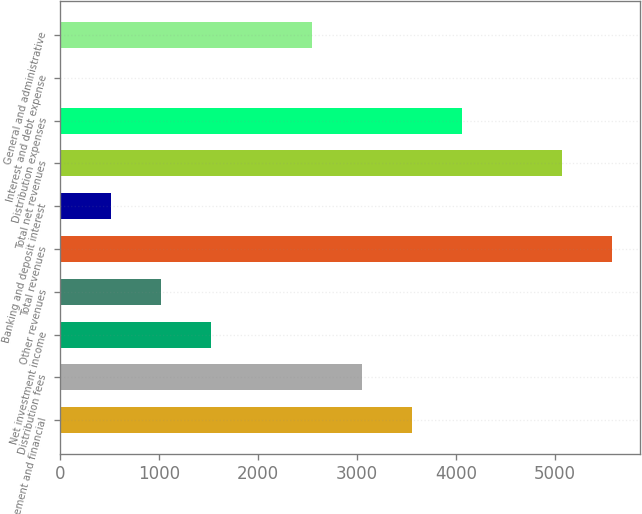Convert chart to OTSL. <chart><loc_0><loc_0><loc_500><loc_500><bar_chart><fcel>Management and financial<fcel>Distribution fees<fcel>Net investment income<fcel>Other revenues<fcel>Total revenues<fcel>Banking and deposit interest<fcel>Total net revenues<fcel>Distribution expenses<fcel>Interest and debt expense<fcel>General and administrative<nl><fcel>3554.9<fcel>3048.2<fcel>1528.1<fcel>1021.4<fcel>5581.7<fcel>514.7<fcel>5075<fcel>4061.6<fcel>8<fcel>2541.5<nl></chart> 